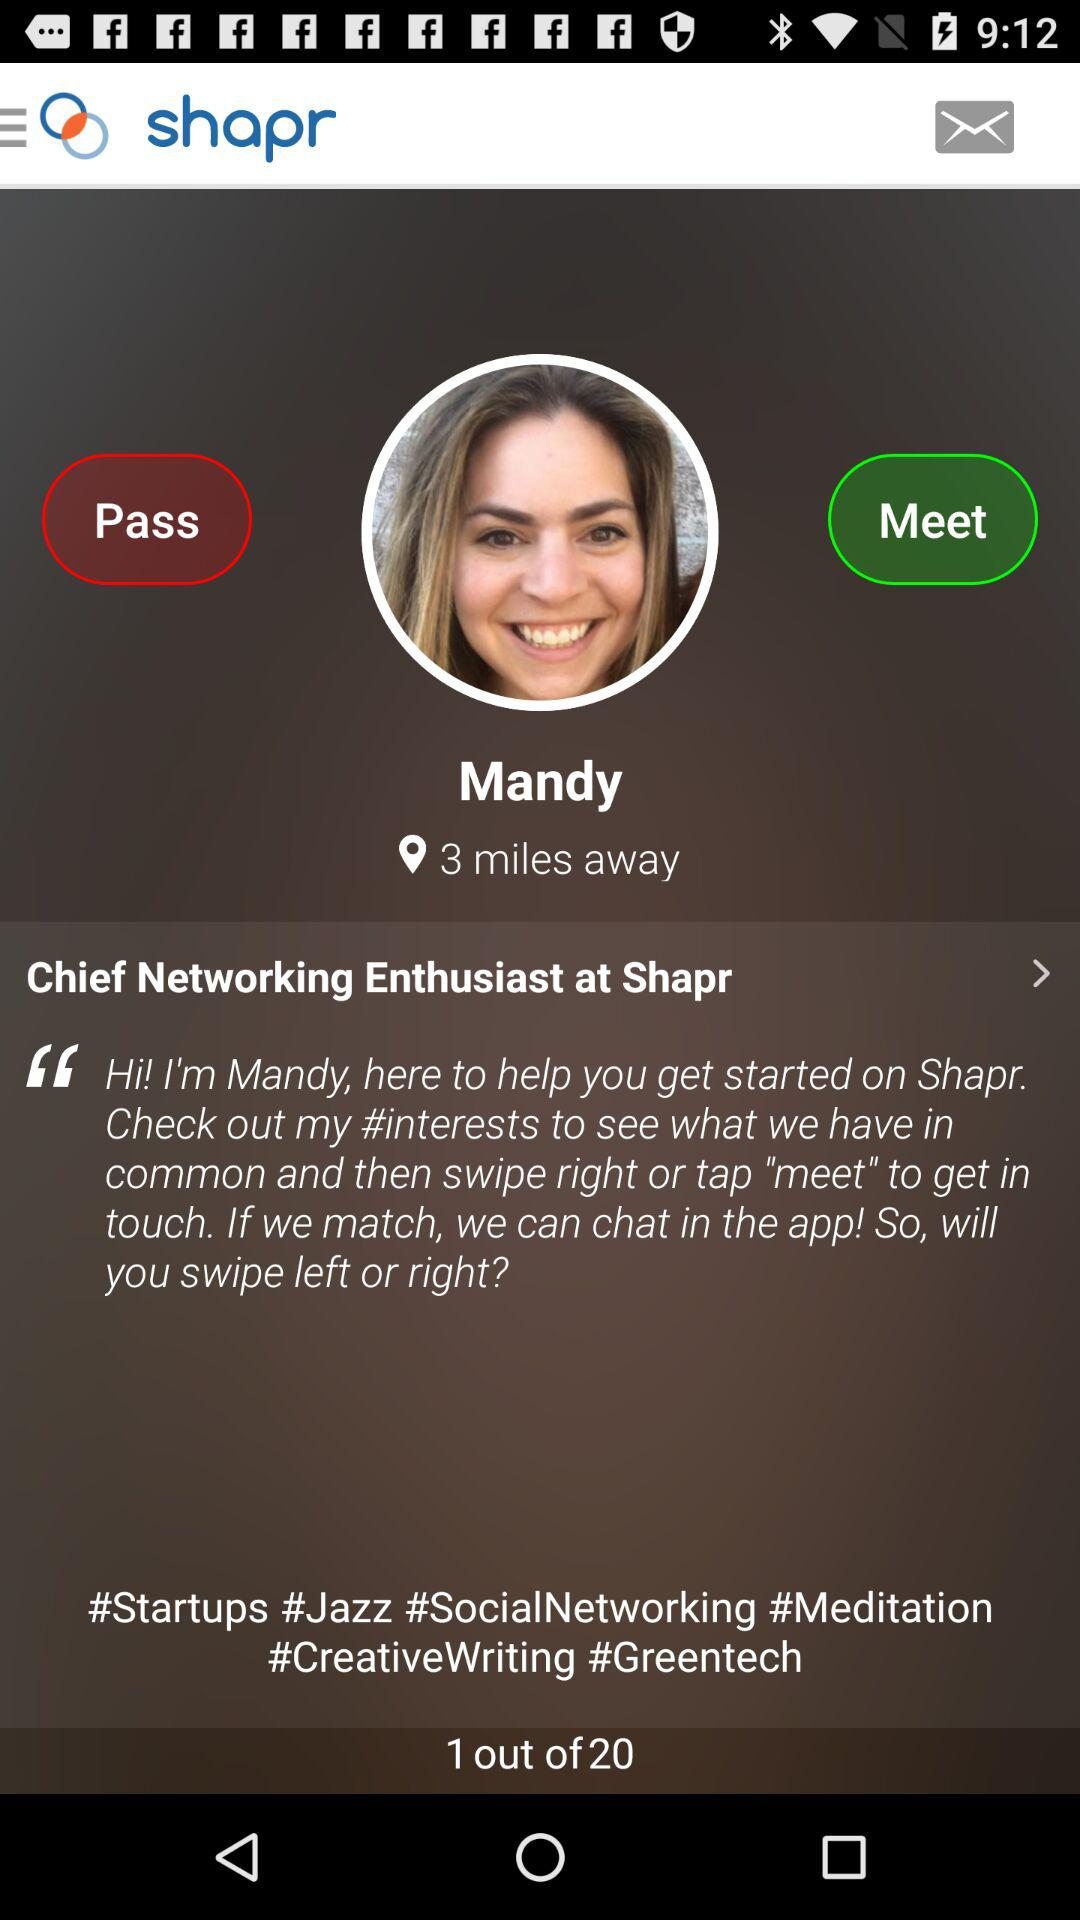What is the name of the user? The name of the user is Mandy. 